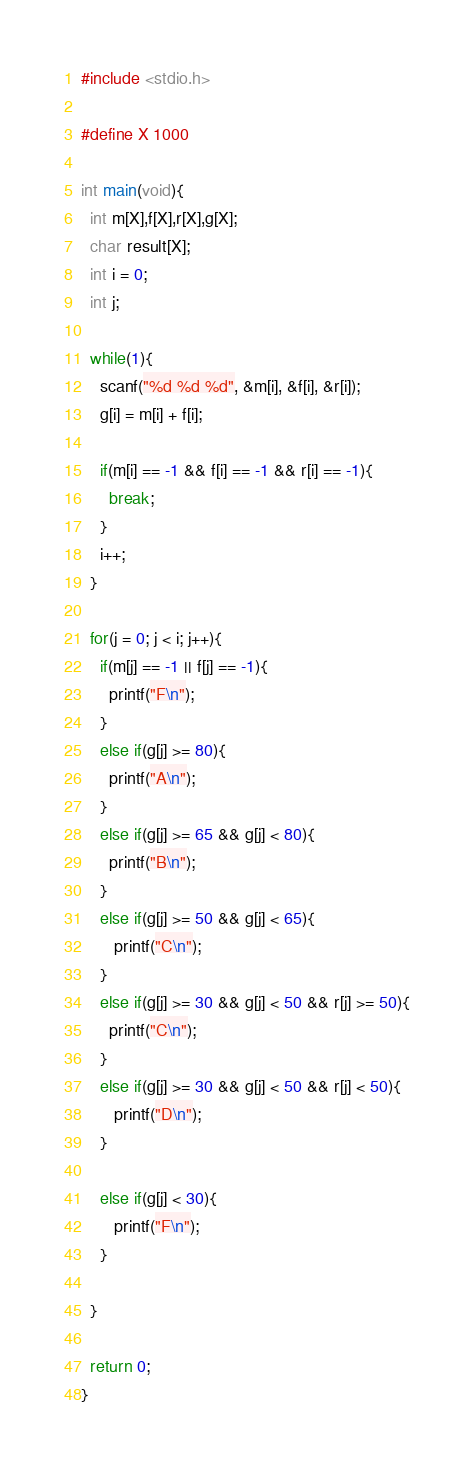Convert code to text. <code><loc_0><loc_0><loc_500><loc_500><_C_>#include <stdio.h>

#define X 1000

int main(void){
  int m[X],f[X],r[X],g[X];
  char result[X];
  int i = 0;
  int j;

  while(1){
    scanf("%d %d %d", &m[i], &f[i], &r[i]);
    g[i] = m[i] + f[i];

    if(m[i] == -1 && f[i] == -1 && r[i] == -1){
      break;
    }
    i++;
  }

  for(j = 0; j < i; j++){
    if(m[j] == -1 || f[j] == -1){
      printf("F\n");
    }
    else if(g[j] >= 80){
      printf("A\n");
    }
    else if(g[j] >= 65 && g[j] < 80){
      printf("B\n");
    }
    else if(g[j] >= 50 && g[j] < 65){
       printf("C\n");
    }
    else if(g[j] >= 30 && g[j] < 50 && r[j] >= 50){
      printf("C\n");
    }
    else if(g[j] >= 30 && g[j] < 50 && r[j] < 50){
       printf("D\n");
    }

    else if(g[j] < 30){
       printf("F\n");
    }

  }

  return 0;
}</code> 